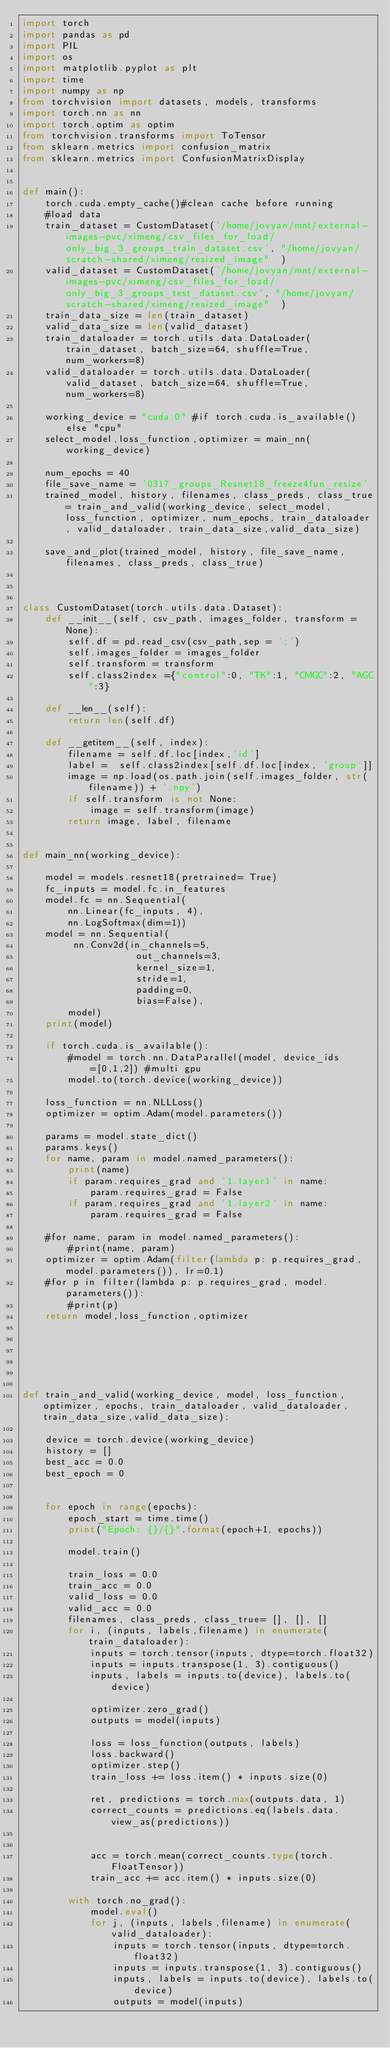Convert code to text. <code><loc_0><loc_0><loc_500><loc_500><_Python_>import torch
import pandas as pd
import PIL
import os
import matplotlib.pyplot as plt
import time
import numpy as np
from torchvision import datasets, models, transforms
import torch.nn as nn
import torch.optim as optim
from torchvision.transforms import ToTensor
from sklearn.metrics import confusion_matrix
from sklearn.metrics import ConfusionMatrixDisplay


def main():
    torch.cuda.empty_cache()#clean cache before running
    #load data
    train_dataset = CustomDataset('/home/jovyan/mnt/external-images-pvc/ximeng/csv_files_for_load/only_big_3_groups_train_dataset.csv', "/home/jovyan/scratch-shared/ximeng/resized_image"  )
    valid_dataset = CustomDataset('/home/jovyan/mnt/external-images-pvc/ximeng/csv_files_for_load/only_big_3_groups_test_dataset.csv', "/home/jovyan/scratch-shared/ximeng/resized_image"  )
    train_data_size = len(train_dataset)
    valid_data_size = len(valid_dataset)
    train_dataloader = torch.utils.data.DataLoader(train_dataset, batch_size=64, shuffle=True, num_workers=8)
    valid_dataloader = torch.utils.data.DataLoader(valid_dataset, batch_size=64, shuffle=True, num_workers=8)
    
    working_device = "cuda:0" #if torch.cuda.is_available() else "cpu"
    select_model,loss_function,optimizer = main_nn(working_device)

    num_epochs = 40
    file_save_name = '0317_groups_Resnet18_freeze4fun_resize'
    trained_model, history, filenames, class_preds, class_true= train_and_valid(working_device, select_model, loss_function, optimizer, num_epochs, train_dataloader, valid_dataloader, train_data_size,valid_data_size)
    
    save_and_plot(trained_model, history, file_save_name, filenames, class_preds, class_true)
    


class CustomDataset(torch.utils.data.Dataset):
    def __init__(self, csv_path, images_folder, transform = None):
        self.df = pd.read_csv(csv_path,sep = ';')
        self.images_folder = images_folder
        self.transform = transform
        self.class2index ={"control":0, "TK":1, "CMGC":2, "AGC":3}

    def __len__(self):
        return len(self.df)

    def __getitem__(self, index):
        filename = self.df.loc[index,'id']
        label =  self.class2index[self.df.loc[index, 'group']]
        image = np.load(os.path.join(self.images_folder, str(filename)) + '.npy')
        if self.transform is not None:
            image = self.transform(image)
        return image, label, filename
       

def main_nn(working_device):
  
    model = models.resnet18(pretrained= True)
    fc_inputs = model.fc.in_features
    model.fc = nn.Sequential(
        nn.Linear(fc_inputs, 4),
        nn.LogSoftmax(dim=1))    
    model = nn.Sequential(
         nn.Conv2d(in_channels=5, 
                    out_channels=3, 
                    kernel_size=1, 
                    stride=1, 
                    padding=0,
                    bias=False),
        model)
    print(model)

    if torch.cuda.is_available():
        #model = torch.nn.DataParallel(model, device_ids=[0,1,2]) #multi gpu
        model.to(torch.device(working_device))

    loss_function = nn.NLLLoss()
    optimizer = optim.Adam(model.parameters())

    params = model.state_dict()
    params.keys()
    for name, param in model.named_parameters():
        print(name)
        if param.requires_grad and '1.layer1' in name:
            param.requires_grad = False
        if param.requires_grad and '1.layer2' in name:
            param.requires_grad = False

    #for name, param in model.named_parameters():
        #print(name, param)
    optimizer = optim.Adam(filter(lambda p: p.requires_grad, model.parameters()), lr=0.1)
    #for p in filter(lambda p: p.requires_grad, model.parameters()):
        #print(p)
    return model,loss_function,optimizer






def train_and_valid(working_device, model, loss_function, optimizer, epochs, train_dataloader, valid_dataloader, train_data_size,valid_data_size):

    device = torch.device(working_device)
    history = []
    best_acc = 0.0
    best_epoch = 0
    
 
    for epoch in range(epochs):
        epoch_start = time.time()
        print("Epoch: {}/{}".format(epoch+1, epochs))
 
        model.train()

        train_loss = 0.0
        train_acc = 0.0
        valid_loss = 0.0
        valid_acc = 0.0
        filenames, class_preds, class_true= [], [], []
        for i, (inputs, labels,filename) in enumerate(train_dataloader):
            inputs = torch.tensor(inputs, dtype=torch.float32)
            inputs = inputs.transpose(1, 3).contiguous()
            inputs, labels = inputs.to(device), labels.to(device)

            optimizer.zero_grad()
            outputs = model(inputs)
 
            loss = loss_function(outputs, labels)
            loss.backward()
            optimizer.step()
            train_loss += loss.item() * inputs.size(0)
 
            ret, predictions = torch.max(outputs.data, 1)
            correct_counts = predictions.eq(labels.data.view_as(predictions))


            acc = torch.mean(correct_counts.type(torch.FloatTensor))
            train_acc += acc.item() * inputs.size(0)
 
        with torch.no_grad():
            model.eval()
            for j, (inputs, labels,filename) in enumerate(valid_dataloader):
                inputs = torch.tensor(inputs, dtype=torch.float32)
                inputs = inputs.transpose(1, 3).contiguous()
                inputs, labels = inputs.to(device), labels.to(device)
                outputs = model(inputs)
 </code> 